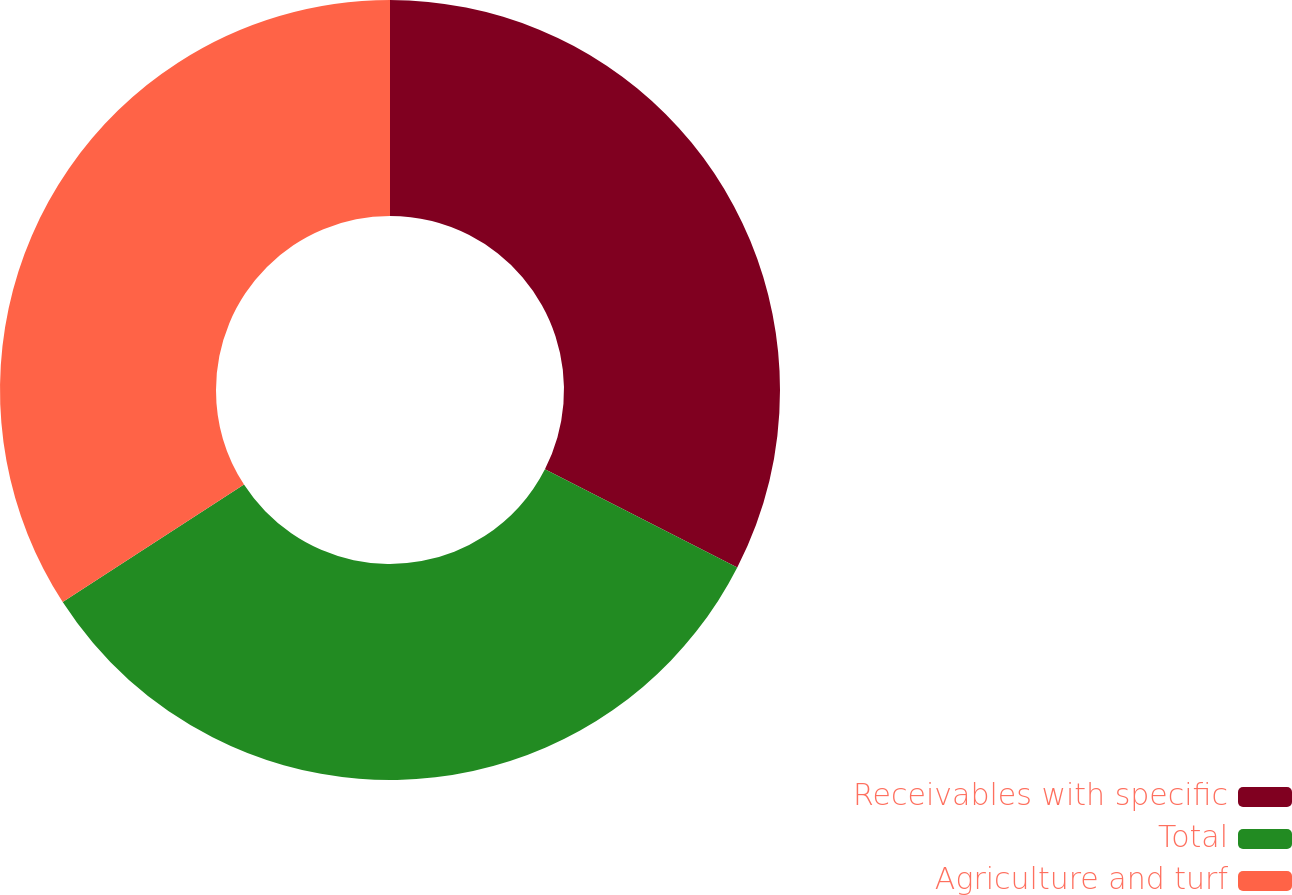Convert chart to OTSL. <chart><loc_0><loc_0><loc_500><loc_500><pie_chart><fcel>Receivables with specific<fcel>Total<fcel>Agriculture and turf<nl><fcel>32.52%<fcel>33.33%<fcel>34.15%<nl></chart> 